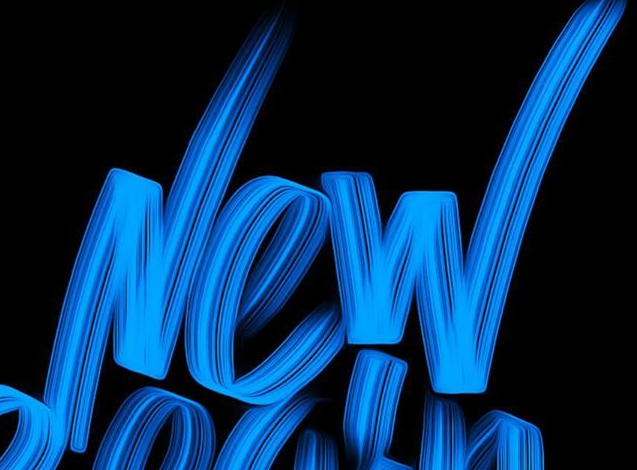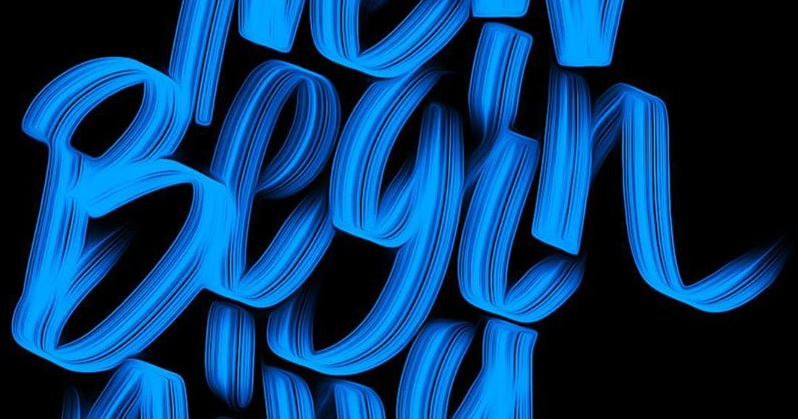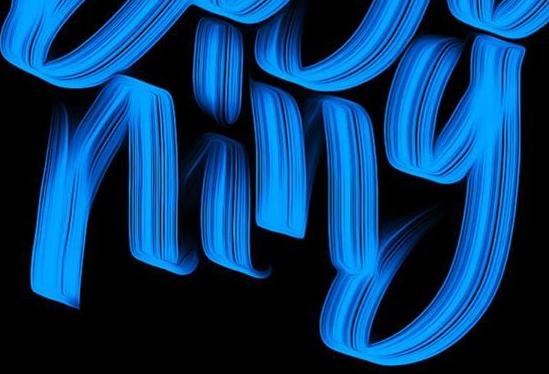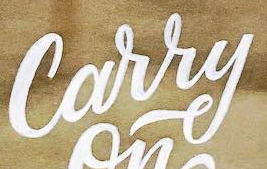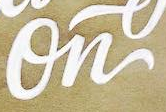Identify the words shown in these images in order, separated by a semicolon. New; Begin; ning; Carry; On 